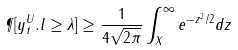Convert formula to latex. <formula><loc_0><loc_0><loc_500><loc_500>\P [ y _ { t } ^ { U } . l \geq \lambda ] \geq \frac { 1 } { 4 \sqrt { 2 \pi } } \int _ { X } ^ { \infty } e ^ { - z ^ { 2 } / 2 } d z</formula> 